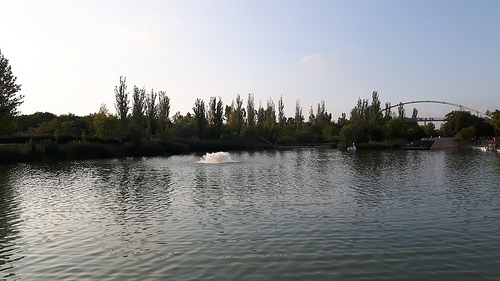<image>
Is there a river in front of the trees? Yes. The river is positioned in front of the trees, appearing closer to the camera viewpoint. 